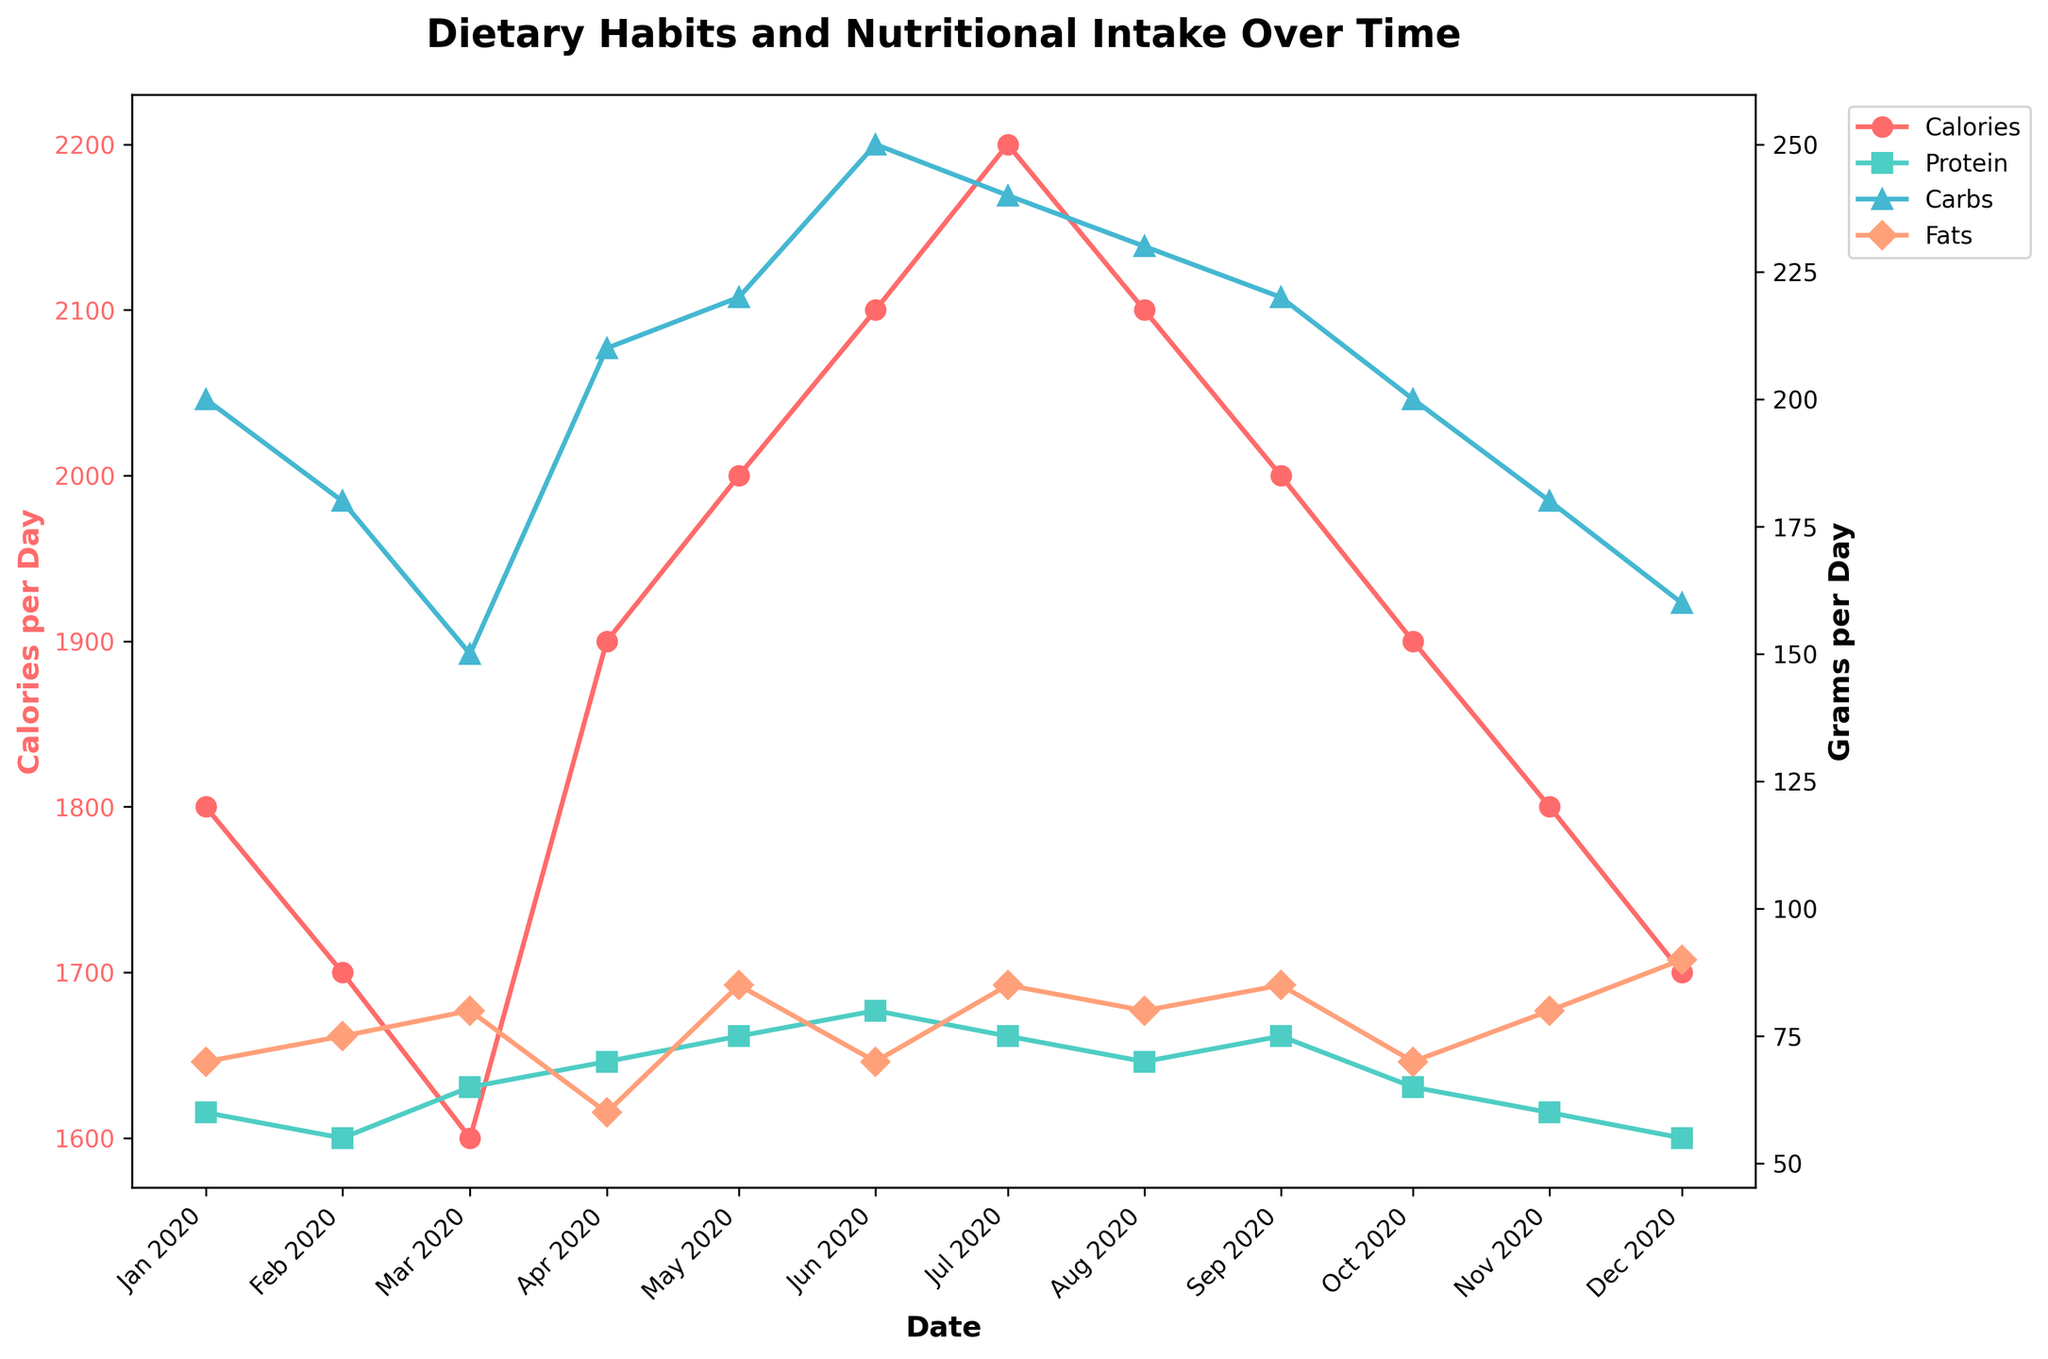What's the title of the plot? The title of the plot is located at the top of the figure and summarizes what the plot is about.
Answer: Dietary Habits and Nutritional Intake Over Time What is the color of the curve representing Calories per Day? The color of each curve is distinguishable by its unique shade. The curve for Calories per Day is distinctly colored.
Answer: Red How many data points are there in the plot for Protein per Day? By counting the markers on the curve representing Protein per Day, which are shown with squares, we can determine the number of data points.
Answer: 12 What month shows the highest calorie intake? By examining the peaks in the red curve representing Calories per Day, we can identify the month with the highest value indicated by a data point with the highest kcal/day.
Answer: July 2020 Is there a month where both protein and fats consumed per day were at their peak? By looking at the curves for both Protein and Fats, and identifying their peaks, we can see if their highest points coincide in the same month.
Answer: July 2020 How does the trend of carbohydrate intake change from January to December? By observing the shape of the curve representing Carbohydrate intake from the start to the end of the year, we can describe if it increases, decreases, fluctuates, or remains constant.
Answer: Fluctuates Was there a significant change in the type of food consumed leading to a noticeable change in calorie intake? By comparing the notes and corresponding changes in calorie intake, we can see any major shifts in the dietary habits. For example, "Abundance of summer fruits" in June often coincides with an increase in calories.
Answer: Yes, there were shifts like in June due to summer fruits Compared to the highest protein intake, what is the protein intake in the month of January? First identify the highest value in the protein curve, then find the value for January and compare the two.
Answer: In January, Protein intake is 60g/day, while the highest is 80g/day in June Which nutrient shows the most variation throughout the year? By examining the spread and amplitude of each curve (Protein, Carbs, Fats), we determine which has the largest differences between its highest and lowest values.
Answer: Carbohydrates What month indicates the lowest fat intake, and what could be the reason? Identify the lowest point on the Fats curve and check the corresponding month and note to find potential reasons.
Answer: April 2020, due to the consumption of Spring Greens and Fresh Fish 